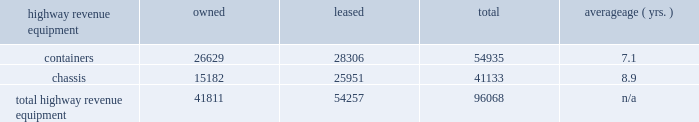Average age ( yrs. ) highway revenue equipment owned leased total .
Capital expenditures our rail network requires significant annual capital investments for replacement , improvement , and expansion .
These investments enhance safety , support the transportation needs of our customers , and improve our operational efficiency .
Additionally , we add new locomotives and freight cars to our fleet to replace older , less efficient equipment , to support growth and customer demand , and to reduce our impact on the environment through the acquisition of more fuel-efficient and low-emission locomotives .
2014 capital program 2013 during 2014 , our capital program totaled $ 4.1 billion .
( see the cash capital expenditures table in management 2019s discussion and analysis of financial condition and results of operations 2013 liquidity and capital resources 2013 financial condition , item 7. ) 2015 capital plan 2013 in 2015 , we expect our capital plan to be approximately $ 4.3 billion , which will include expenditures for ptc of approximately $ 450 million and may include non-cash investments .
We may revise our 2015 capital plan if business conditions warrant or if new laws or regulations affect our ability to generate sufficient returns on these investments .
( see discussion of our 2015 capital plan in management 2019s discussion and analysis of financial condition and results of operations 2013 2015 outlook , item 7. ) equipment encumbrances 2013 equipment with a carrying value of approximately $ 2.8 billion and $ 2.9 billion at december 31 , 2014 , and 2013 , respectively served as collateral for capital leases and other types of equipment obligations in accordance with the secured financing arrangements utilized to acquire or refinance such railroad equipment .
As a result of the merger of missouri pacific railroad company ( mprr ) with and into uprr on january 1 , 1997 , and pursuant to the underlying indentures for the mprr mortgage bonds , uprr must maintain the same value of assets after the merger in order to comply with the security requirements of the mortgage bonds .
As of the merger date , the value of the mprr assets that secured the mortgage bonds was approximately $ 6.0 billion .
In accordance with the terms of the indentures , this collateral value must be maintained during the entire term of the mortgage bonds irrespective of the outstanding balance of such bonds .
Environmental matters 2013 certain of our properties are subject to federal , state , and local laws and regulations governing the protection of the environment .
( see discussion of environmental issues in business 2013 governmental and environmental regulation , item 1 , and management 2019s discussion and analysis of financial condition and results of operations 2013 critical accounting policies 2013 environmental , item 7. ) item 3 .
Legal proceedings from time to time , we are involved in legal proceedings , claims , and litigation that occur in connection with our business .
We routinely assess our liabilities and contingencies in connection with these matters based upon the latest available information and , when necessary , we seek input from our third-party advisors when making these assessments .
Consistent with sec rules and requirements , we describe below material pending legal proceedings ( other than ordinary routine litigation incidental to our business ) , material proceedings known to be contemplated by governmental authorities , other proceedings arising under federal , state , or local environmental laws and regulations ( including governmental proceedings involving potential fines , penalties , or other monetary sanctions in excess of $ 100000 ) , and such other pending matters that we may determine to be appropriate. .
What percentage of containers are owned? 
Computations: (26629 / 54935)
Answer: 0.48474. Average age ( yrs. ) highway revenue equipment owned leased total .
Capital expenditures our rail network requires significant annual capital investments for replacement , improvement , and expansion .
These investments enhance safety , support the transportation needs of our customers , and improve our operational efficiency .
Additionally , we add new locomotives and freight cars to our fleet to replace older , less efficient equipment , to support growth and customer demand , and to reduce our impact on the environment through the acquisition of more fuel-efficient and low-emission locomotives .
2014 capital program 2013 during 2014 , our capital program totaled $ 4.1 billion .
( see the cash capital expenditures table in management 2019s discussion and analysis of financial condition and results of operations 2013 liquidity and capital resources 2013 financial condition , item 7. ) 2015 capital plan 2013 in 2015 , we expect our capital plan to be approximately $ 4.3 billion , which will include expenditures for ptc of approximately $ 450 million and may include non-cash investments .
We may revise our 2015 capital plan if business conditions warrant or if new laws or regulations affect our ability to generate sufficient returns on these investments .
( see discussion of our 2015 capital plan in management 2019s discussion and analysis of financial condition and results of operations 2013 2015 outlook , item 7. ) equipment encumbrances 2013 equipment with a carrying value of approximately $ 2.8 billion and $ 2.9 billion at december 31 , 2014 , and 2013 , respectively served as collateral for capital leases and other types of equipment obligations in accordance with the secured financing arrangements utilized to acquire or refinance such railroad equipment .
As a result of the merger of missouri pacific railroad company ( mprr ) with and into uprr on january 1 , 1997 , and pursuant to the underlying indentures for the mprr mortgage bonds , uprr must maintain the same value of assets after the merger in order to comply with the security requirements of the mortgage bonds .
As of the merger date , the value of the mprr assets that secured the mortgage bonds was approximately $ 6.0 billion .
In accordance with the terms of the indentures , this collateral value must be maintained during the entire term of the mortgage bonds irrespective of the outstanding balance of such bonds .
Environmental matters 2013 certain of our properties are subject to federal , state , and local laws and regulations governing the protection of the environment .
( see discussion of environmental issues in business 2013 governmental and environmental regulation , item 1 , and management 2019s discussion and analysis of financial condition and results of operations 2013 critical accounting policies 2013 environmental , item 7. ) item 3 .
Legal proceedings from time to time , we are involved in legal proceedings , claims , and litigation that occur in connection with our business .
We routinely assess our liabilities and contingencies in connection with these matters based upon the latest available information and , when necessary , we seek input from our third-party advisors when making these assessments .
Consistent with sec rules and requirements , we describe below material pending legal proceedings ( other than ordinary routine litigation incidental to our business ) , material proceedings known to be contemplated by governmental authorities , other proceedings arising under federal , state , or local environmental laws and regulations ( including governmental proceedings involving potential fines , penalties , or other monetary sanctions in excess of $ 100000 ) , and such other pending matters that we may determine to be appropriate. .
What percentage of total highway revenue equipment is owned? 
Computations: (41811 / 96068)
Answer: 0.43522. Average age ( yrs. ) highway revenue equipment owned leased total .
Capital expenditures our rail network requires significant annual capital investments for replacement , improvement , and expansion .
These investments enhance safety , support the transportation needs of our customers , and improve our operational efficiency .
Additionally , we add new locomotives and freight cars to our fleet to replace older , less efficient equipment , to support growth and customer demand , and to reduce our impact on the environment through the acquisition of more fuel-efficient and low-emission locomotives .
2014 capital program 2013 during 2014 , our capital program totaled $ 4.1 billion .
( see the cash capital expenditures table in management 2019s discussion and analysis of financial condition and results of operations 2013 liquidity and capital resources 2013 financial condition , item 7. ) 2015 capital plan 2013 in 2015 , we expect our capital plan to be approximately $ 4.3 billion , which will include expenditures for ptc of approximately $ 450 million and may include non-cash investments .
We may revise our 2015 capital plan if business conditions warrant or if new laws or regulations affect our ability to generate sufficient returns on these investments .
( see discussion of our 2015 capital plan in management 2019s discussion and analysis of financial condition and results of operations 2013 2015 outlook , item 7. ) equipment encumbrances 2013 equipment with a carrying value of approximately $ 2.8 billion and $ 2.9 billion at december 31 , 2014 , and 2013 , respectively served as collateral for capital leases and other types of equipment obligations in accordance with the secured financing arrangements utilized to acquire or refinance such railroad equipment .
As a result of the merger of missouri pacific railroad company ( mprr ) with and into uprr on january 1 , 1997 , and pursuant to the underlying indentures for the mprr mortgage bonds , uprr must maintain the same value of assets after the merger in order to comply with the security requirements of the mortgage bonds .
As of the merger date , the value of the mprr assets that secured the mortgage bonds was approximately $ 6.0 billion .
In accordance with the terms of the indentures , this collateral value must be maintained during the entire term of the mortgage bonds irrespective of the outstanding balance of such bonds .
Environmental matters 2013 certain of our properties are subject to federal , state , and local laws and regulations governing the protection of the environment .
( see discussion of environmental issues in business 2013 governmental and environmental regulation , item 1 , and management 2019s discussion and analysis of financial condition and results of operations 2013 critical accounting policies 2013 environmental , item 7. ) item 3 .
Legal proceedings from time to time , we are involved in legal proceedings , claims , and litigation that occur in connection with our business .
We routinely assess our liabilities and contingencies in connection with these matters based upon the latest available information and , when necessary , we seek input from our third-party advisors when making these assessments .
Consistent with sec rules and requirements , we describe below material pending legal proceedings ( other than ordinary routine litigation incidental to our business ) , material proceedings known to be contemplated by governmental authorities , other proceedings arising under federal , state , or local environmental laws and regulations ( including governmental proceedings involving potential fines , penalties , or other monetary sanctions in excess of $ 100000 ) , and such other pending matters that we may determine to be appropriate. .
What percentage of owned total highway revenue equipment is containers? 
Computations: (26629 / 41811)
Answer: 0.63689. 